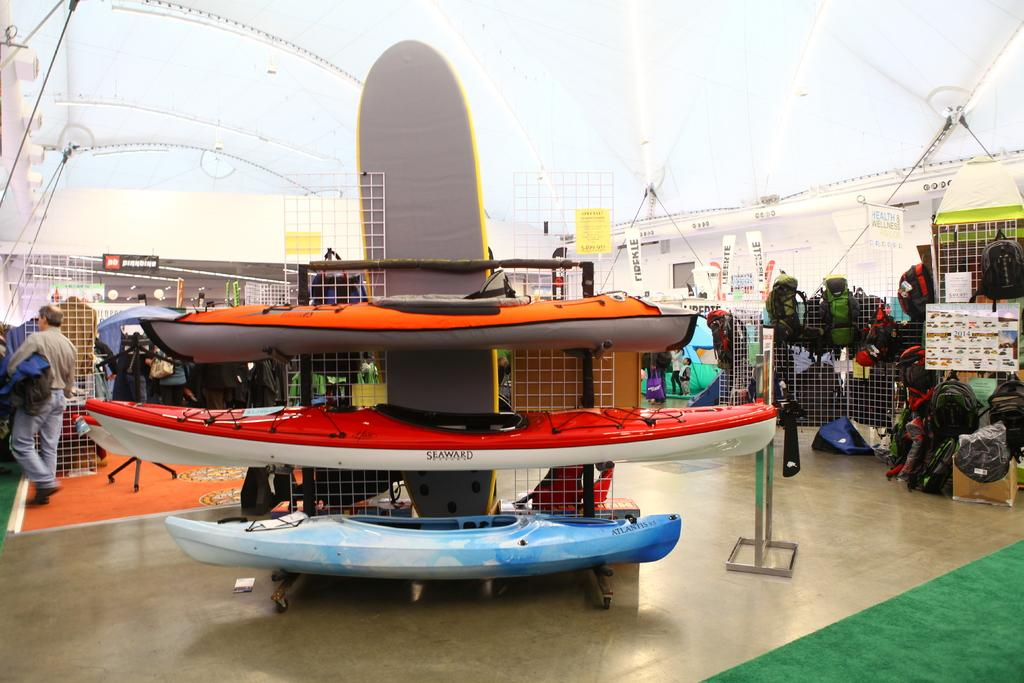What is the primary object in the image? There is a net in the image. What else can be seen in the image besides the net? There are bags, unspecified things, people, and boards in the image. Can you describe the people in the image? The provided facts do not specify any details about the people in the image. What might the boards be used for? The purpose of the boards in the image is not specified in the provided facts. What type of silver object is present in the image? There is no silver object present in the image. Can you hear the voice of the person in the image? The provided facts do not mention any sound or voice in the image. 